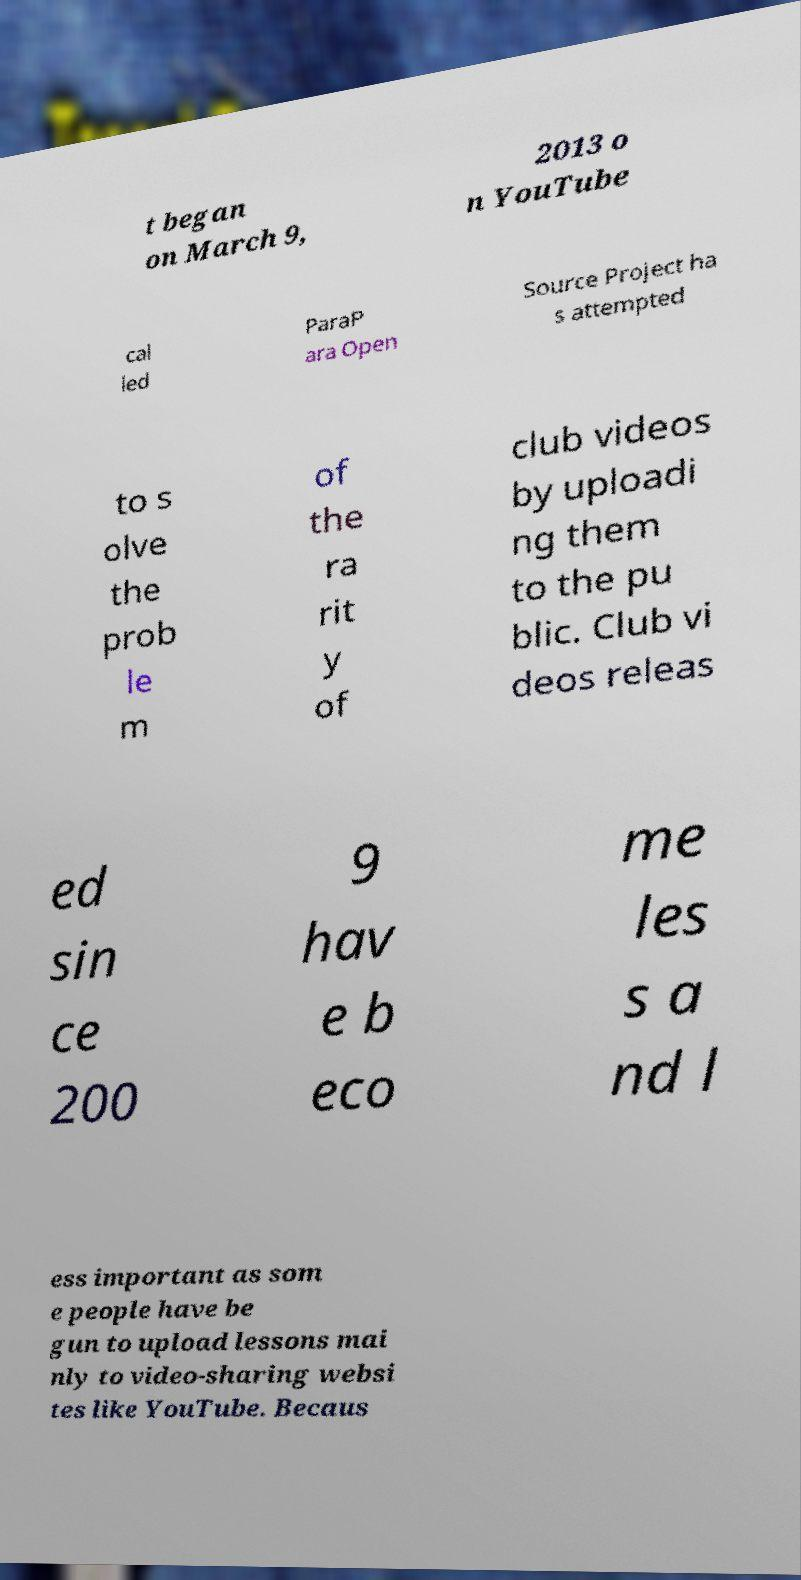Could you extract and type out the text from this image? t began on March 9, 2013 o n YouTube cal led ParaP ara Open Source Project ha s attempted to s olve the prob le m of the ra rit y of club videos by uploadi ng them to the pu blic. Club vi deos releas ed sin ce 200 9 hav e b eco me les s a nd l ess important as som e people have be gun to upload lessons mai nly to video-sharing websi tes like YouTube. Becaus 